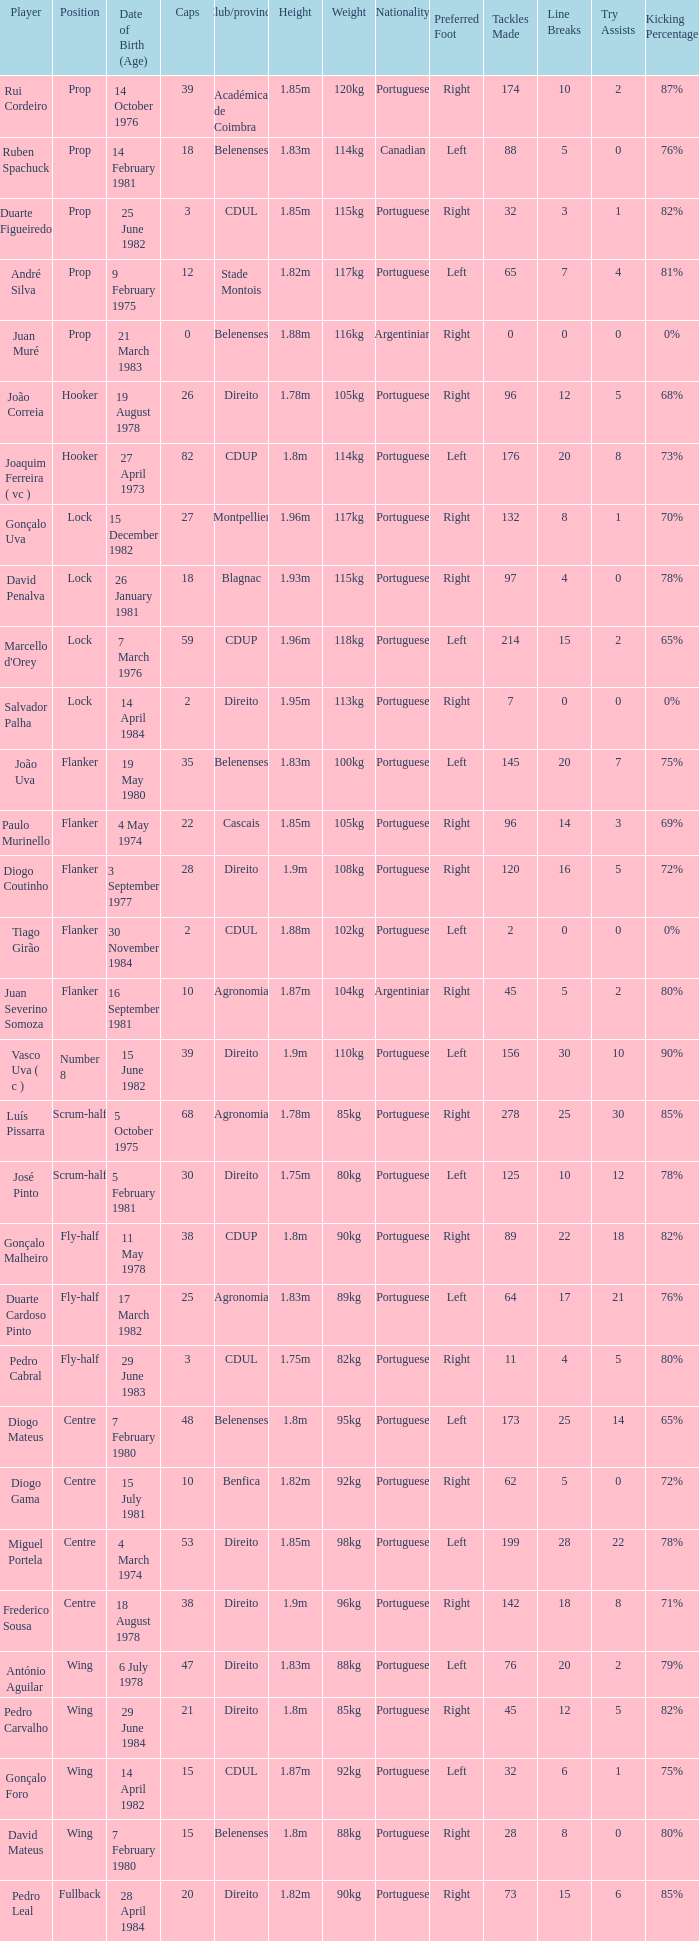Which Club/province has a Player of david penalva? Blagnac. 